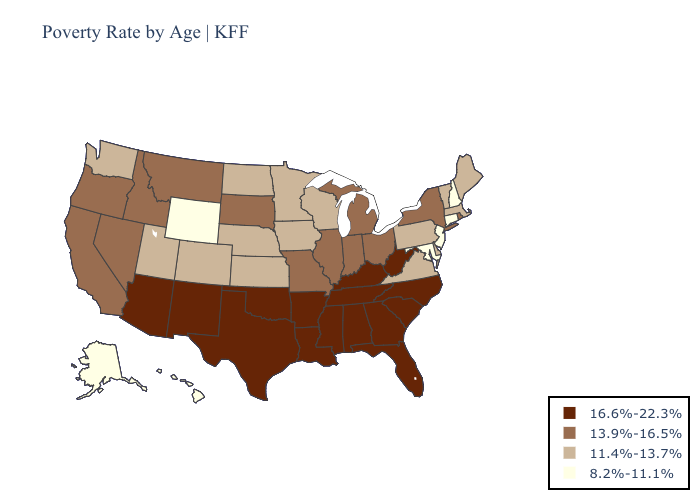What is the highest value in the South ?
Answer briefly. 16.6%-22.3%. Name the states that have a value in the range 16.6%-22.3%?
Concise answer only. Alabama, Arizona, Arkansas, Florida, Georgia, Kentucky, Louisiana, Mississippi, New Mexico, North Carolina, Oklahoma, South Carolina, Tennessee, Texas, West Virginia. Does Utah have the highest value in the USA?
Give a very brief answer. No. Does South Carolina have the highest value in the USA?
Keep it brief. Yes. What is the value of Oregon?
Write a very short answer. 13.9%-16.5%. What is the highest value in the USA?
Write a very short answer. 16.6%-22.3%. What is the value of Texas?
Quick response, please. 16.6%-22.3%. Among the states that border Indiana , which have the highest value?
Keep it brief. Kentucky. Is the legend a continuous bar?
Keep it brief. No. What is the value of Maryland?
Short answer required. 8.2%-11.1%. What is the lowest value in the USA?
Concise answer only. 8.2%-11.1%. Among the states that border Delaware , does Pennsylvania have the highest value?
Short answer required. Yes. What is the highest value in the USA?
Keep it brief. 16.6%-22.3%. Name the states that have a value in the range 11.4%-13.7%?
Short answer required. Colorado, Delaware, Iowa, Kansas, Maine, Massachusetts, Minnesota, Nebraska, North Dakota, Pennsylvania, Utah, Vermont, Virginia, Washington, Wisconsin. What is the value of Virginia?
Write a very short answer. 11.4%-13.7%. 